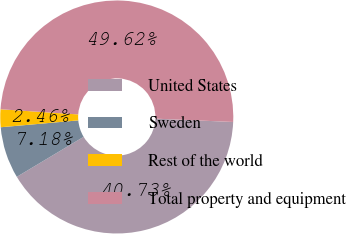<chart> <loc_0><loc_0><loc_500><loc_500><pie_chart><fcel>United States<fcel>Sweden<fcel>Rest of the world<fcel>Total property and equipment<nl><fcel>40.73%<fcel>7.18%<fcel>2.46%<fcel>49.62%<nl></chart> 